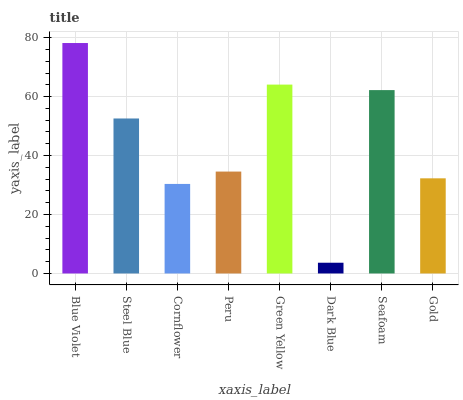Is Dark Blue the minimum?
Answer yes or no. Yes. Is Blue Violet the maximum?
Answer yes or no. Yes. Is Steel Blue the minimum?
Answer yes or no. No. Is Steel Blue the maximum?
Answer yes or no. No. Is Blue Violet greater than Steel Blue?
Answer yes or no. Yes. Is Steel Blue less than Blue Violet?
Answer yes or no. Yes. Is Steel Blue greater than Blue Violet?
Answer yes or no. No. Is Blue Violet less than Steel Blue?
Answer yes or no. No. Is Steel Blue the high median?
Answer yes or no. Yes. Is Peru the low median?
Answer yes or no. Yes. Is Gold the high median?
Answer yes or no. No. Is Steel Blue the low median?
Answer yes or no. No. 